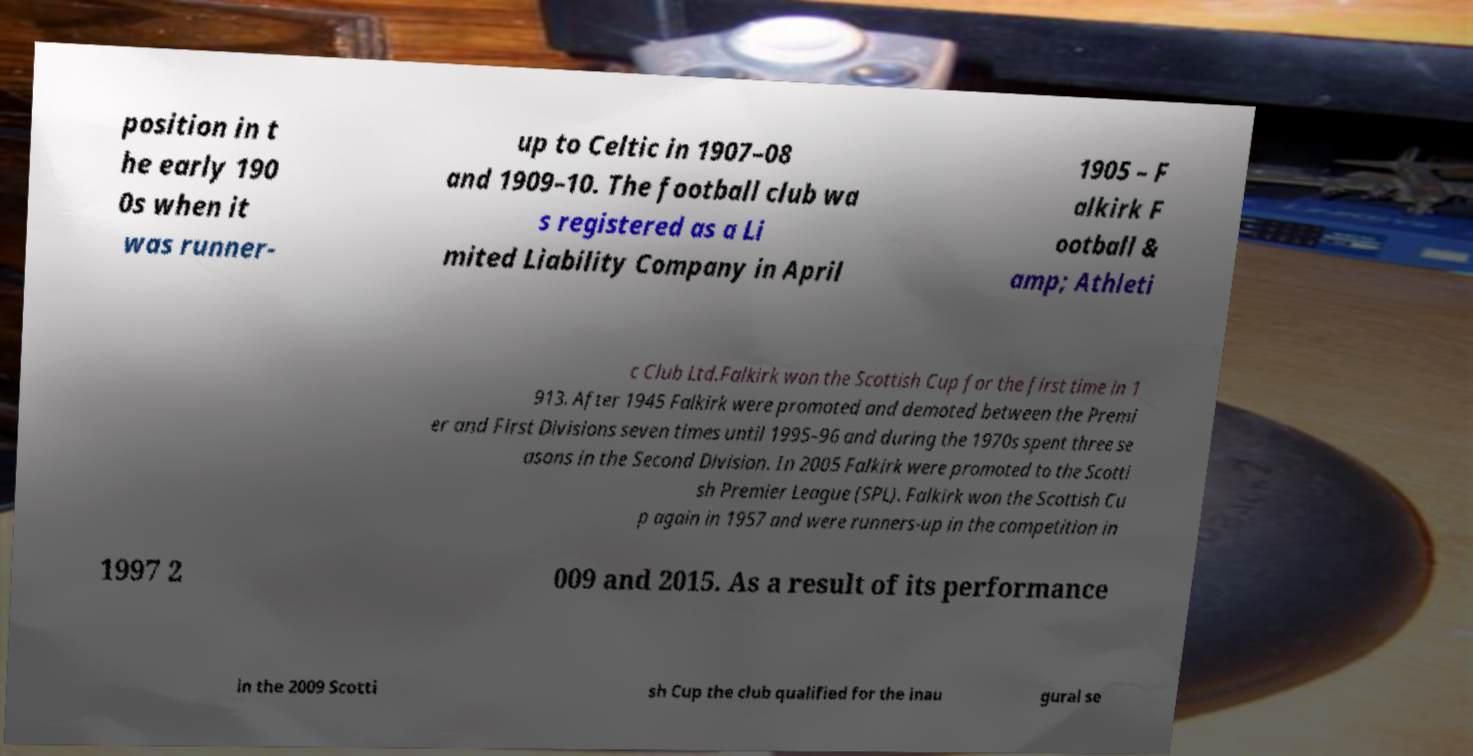Please read and relay the text visible in this image. What does it say? position in t he early 190 0s when it was runner- up to Celtic in 1907–08 and 1909–10. The football club wa s registered as a Li mited Liability Company in April 1905 – F alkirk F ootball & amp; Athleti c Club Ltd.Falkirk won the Scottish Cup for the first time in 1 913. After 1945 Falkirk were promoted and demoted between the Premi er and First Divisions seven times until 1995–96 and during the 1970s spent three se asons in the Second Division. In 2005 Falkirk were promoted to the Scotti sh Premier League (SPL). Falkirk won the Scottish Cu p again in 1957 and were runners-up in the competition in 1997 2 009 and 2015. As a result of its performance in the 2009 Scotti sh Cup the club qualified for the inau gural se 